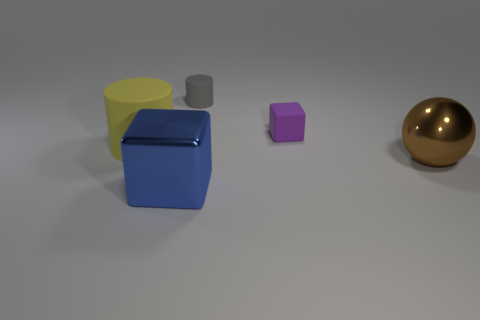Add 1 big cylinders. How many objects exist? 6 Subtract 1 cylinders. How many cylinders are left? 1 Subtract all purple cylinders. How many purple cubes are left? 1 Subtract 1 yellow cylinders. How many objects are left? 4 Subtract all spheres. How many objects are left? 4 Subtract all blue spheres. Subtract all green cylinders. How many spheres are left? 1 Subtract all large brown shiny spheres. Subtract all big matte objects. How many objects are left? 3 Add 3 small gray rubber cylinders. How many small gray rubber cylinders are left? 4 Add 4 brown shiny things. How many brown shiny things exist? 5 